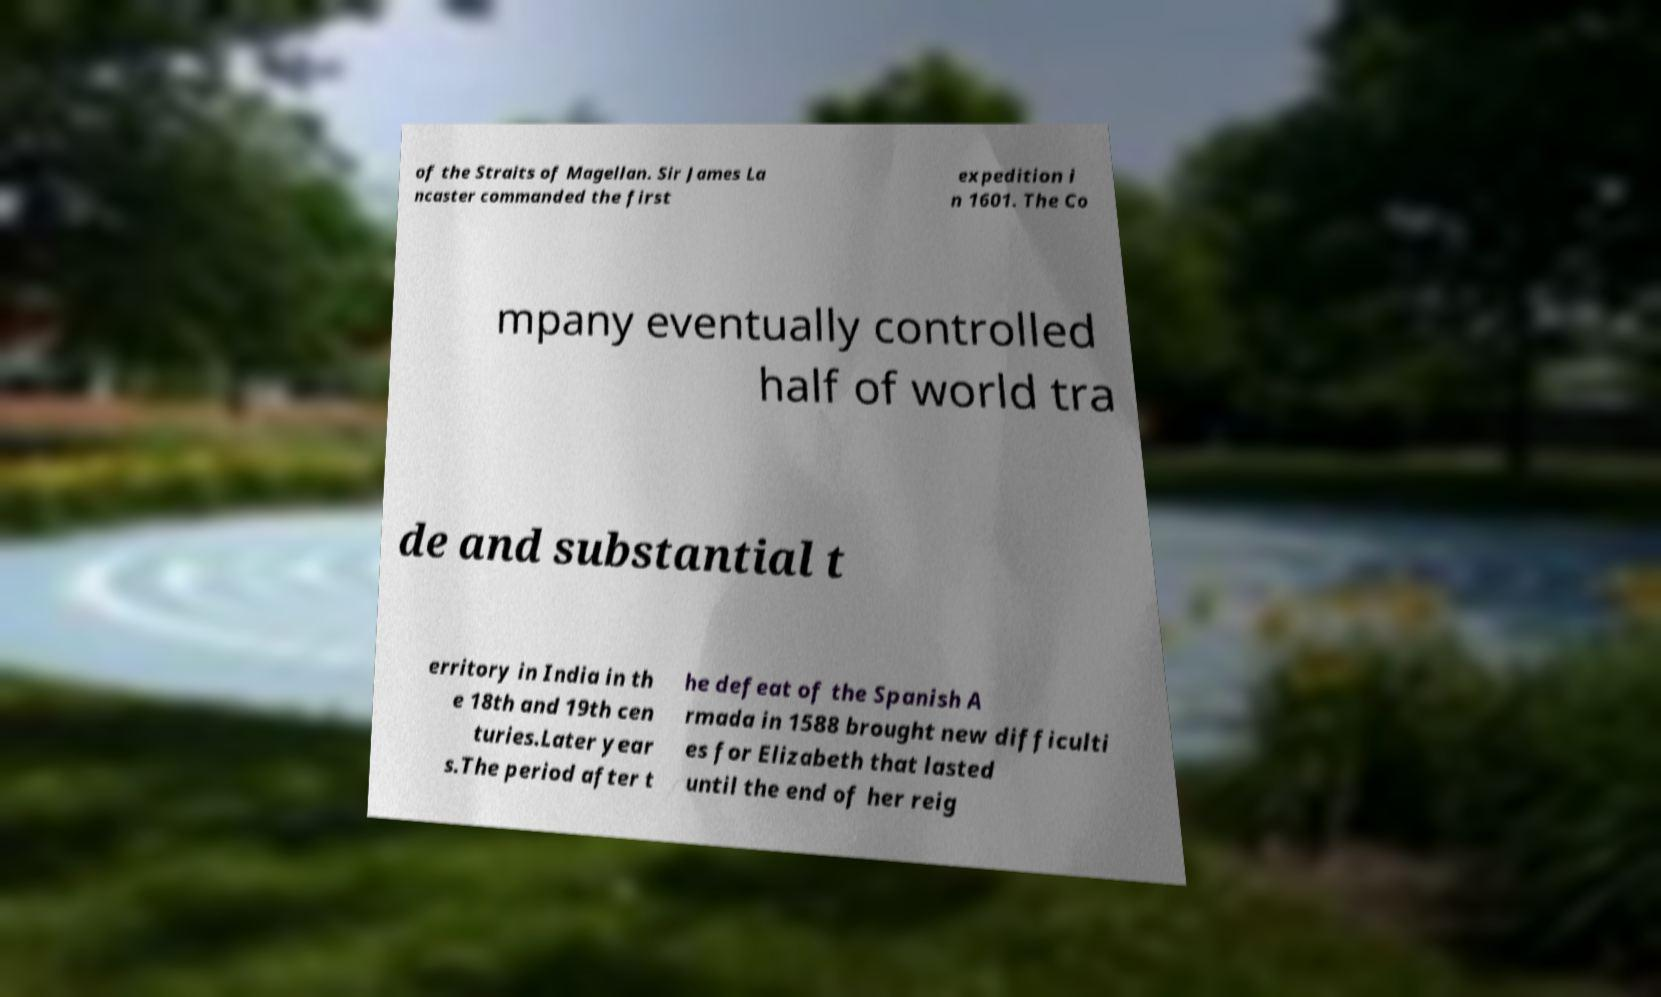Please read and relay the text visible in this image. What does it say? of the Straits of Magellan. Sir James La ncaster commanded the first expedition i n 1601. The Co mpany eventually controlled half of world tra de and substantial t erritory in India in th e 18th and 19th cen turies.Later year s.The period after t he defeat of the Spanish A rmada in 1588 brought new difficulti es for Elizabeth that lasted until the end of her reig 